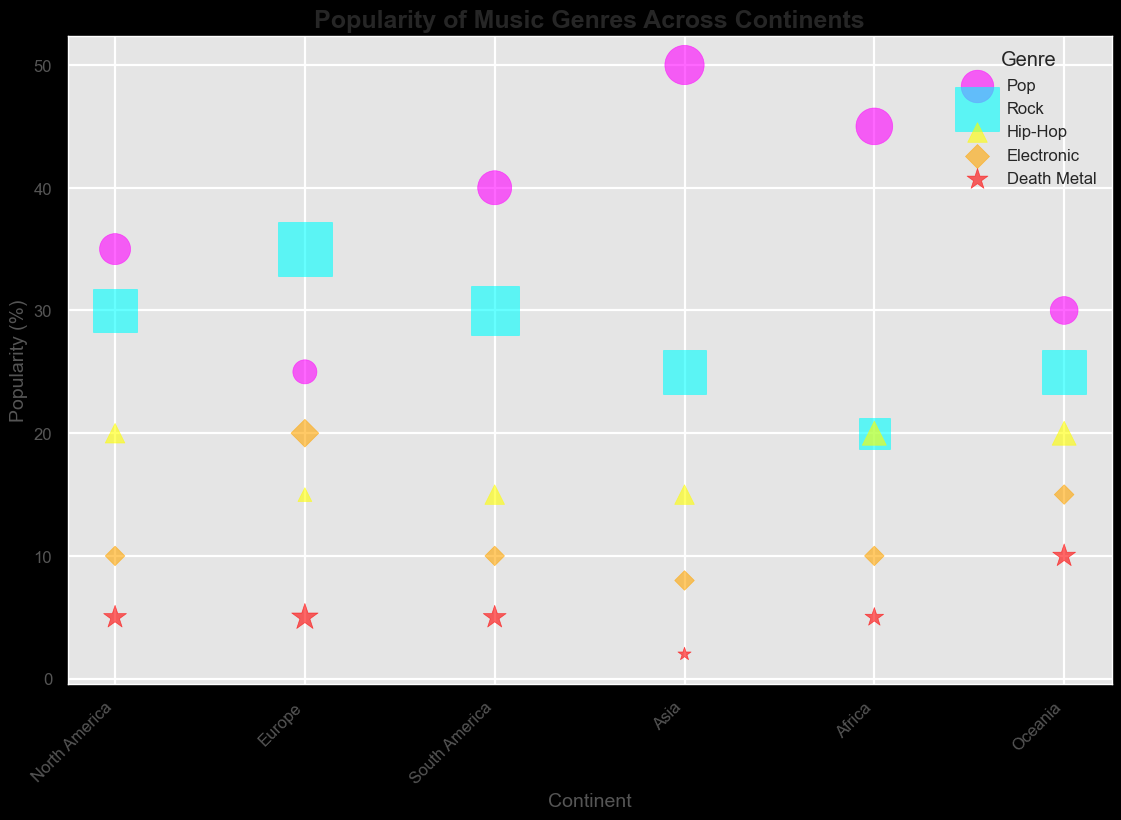What continent has the highest popularity for Death Metal based on the figure? By observing the red star markers (Death Metal) in the figure, find the continent with the highest y-value (popularity). Oceania has a red star at y=10, which is the highest among all continents.
Answer: Oceania Which genre has the highest popularity in Asia? In the figure, look for the bubbles over the "Asia" label on the x-axis. Among these, the magenta circle (Pop) is at the highest y-value of 50.
Answer: Pop What's the total popularity of Rock and Death Metal in North America? Sum the popularity values of Rock and Death Metal as indicated for North America in the chart. Rock has a popularity of 30 and Death Metal has 5, so 30 + 5 = 35.
Answer: 35 How does the Death Metal fan base in Europe compare to that in Africa? Compare the size of the red stars (Death Metal markers) in Europe and Africa. Europe's marker is slightly larger, indicating it has more fans. Specifically, Europe has 4 fans, whereas Africa has 2.
Answer: Europe has more Which continent has the lowest popularity for Electronic music? Observe the orange diamond markers (Electronic) and find the smallest y-value across all continents. Asia has the lowest at a y-value of 8.
Answer: Asia Which genre in South America has the largest number of Death Metal fans? For South America, compare the sizes of the markers. The largest red star (Death Metal) has a size indicating 12 fans for Rock.
Answer: Rock What’s the average popularity of Pop music across all continents? Identify the magenta circles (Pop) on all continents and compute the average of their popularity: (35 + 25 + 40 + 50 + 45 + 30) / 6 = 225 / 6 = 37.5.
Answer: 37.5 Compare the popularity of Hip-Hop in Africa and North America. Which one is higher? Look at the yellow triangles (Hip-Hop) for Africa and North America. Both are at a y-value of 20.
Answer: Equal How many continents have a higher popularity of Rock than Hip-Hop? Compare the y-values of cyan squares (Rock) and yellow triangles (Hip-Hop) for each continent: North America, Europe, South America, Asia, Africa, and Oceania. North America, Europe, South America, Asia, and Oceania have Rock higher than Hip-Hop; Africa is equal.
Answer: 5 What's the difference in popularity of Electronic music between Europe and Oceania? Subtract the y-value of Oceania’s Electronic (15) from Europe's Electronic (20): 20 - 15 = 5.
Answer: 5 